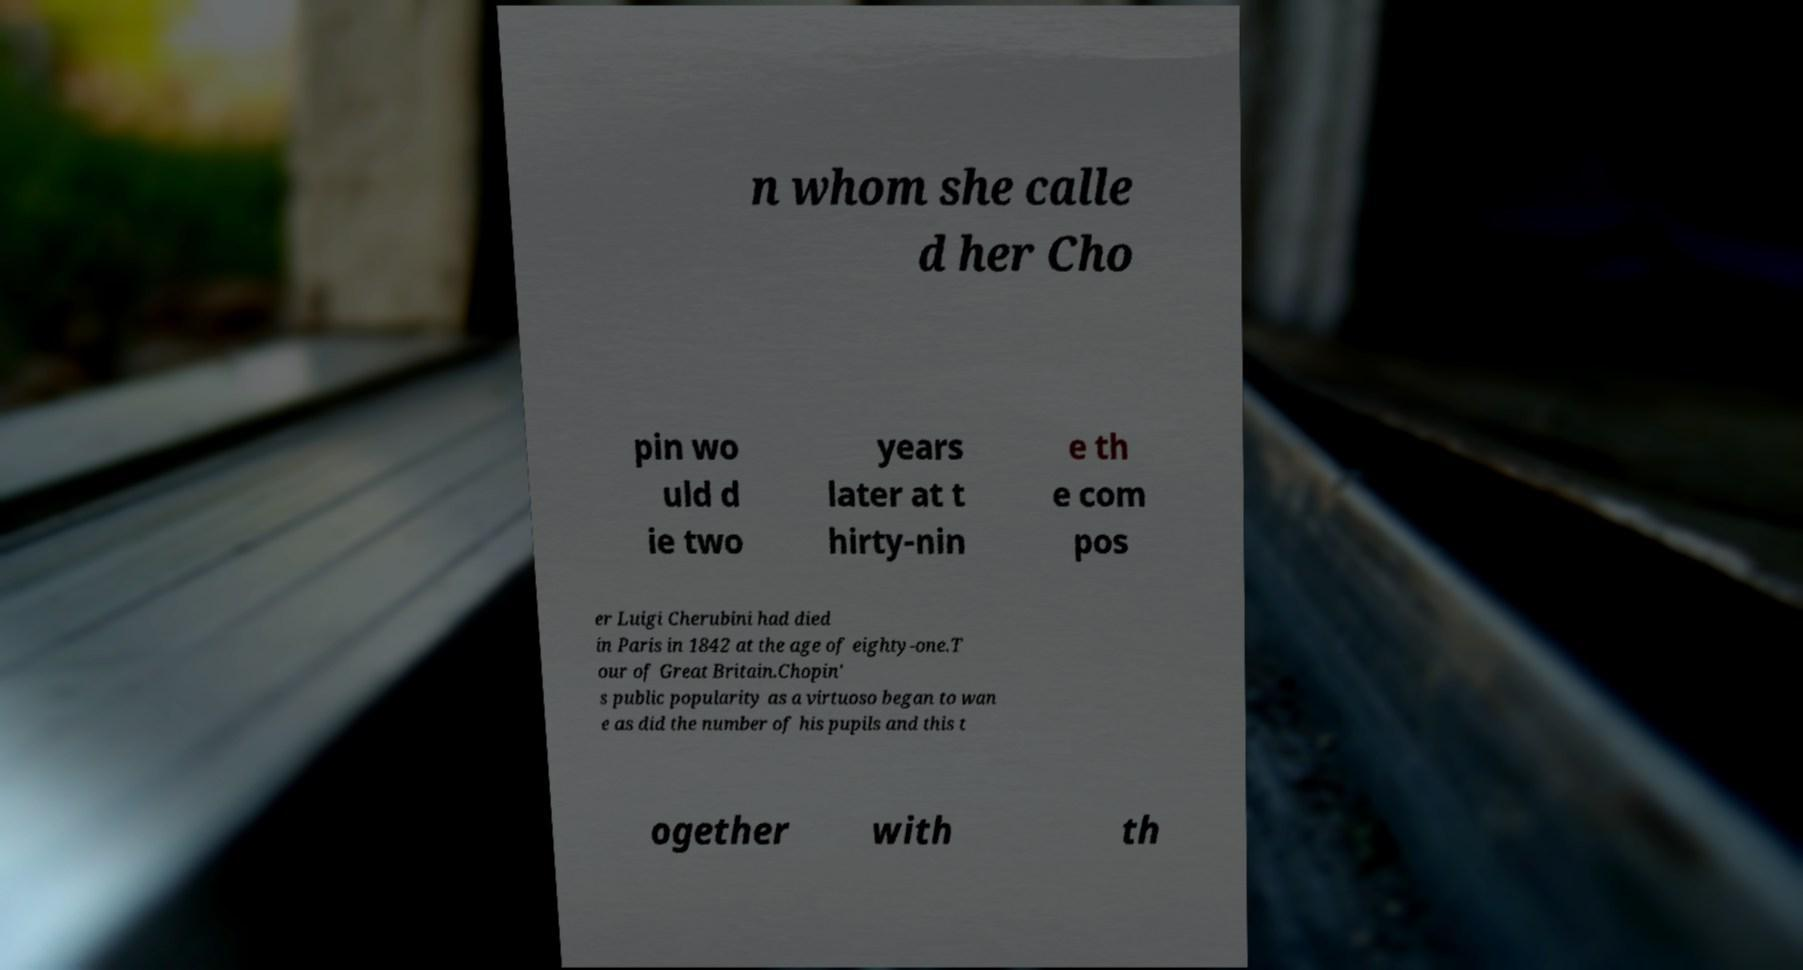Can you accurately transcribe the text from the provided image for me? n whom she calle d her Cho pin wo uld d ie two years later at t hirty-nin e th e com pos er Luigi Cherubini had died in Paris in 1842 at the age of eighty-one.T our of Great Britain.Chopin' s public popularity as a virtuoso began to wan e as did the number of his pupils and this t ogether with th 